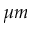<formula> <loc_0><loc_0><loc_500><loc_500>\mu m</formula> 